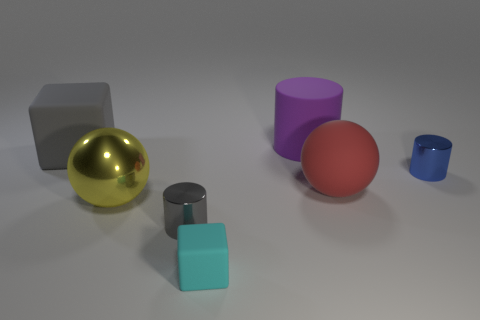Subtract all tiny blue shiny cylinders. How many cylinders are left? 2 Subtract all blue cylinders. How many cylinders are left? 2 Add 1 metal spheres. How many objects exist? 8 Subtract 1 cubes. How many cubes are left? 1 Subtract all purple spheres. Subtract all yellow blocks. How many spheres are left? 2 Subtract all brown cylinders. How many blue blocks are left? 0 Subtract all small cubes. Subtract all big purple matte cylinders. How many objects are left? 5 Add 2 matte spheres. How many matte spheres are left? 3 Add 6 large cyan rubber balls. How many large cyan rubber balls exist? 6 Subtract 0 brown cylinders. How many objects are left? 7 